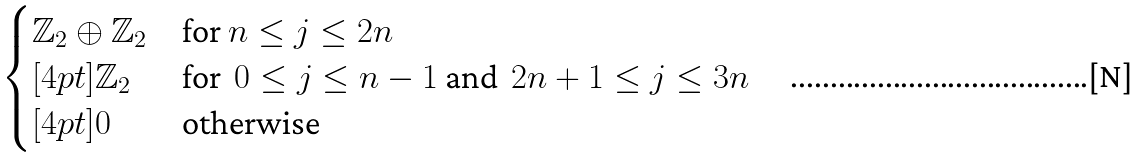<formula> <loc_0><loc_0><loc_500><loc_500>\begin{cases} \mathbb { Z } _ { 2 } \oplus \mathbb { Z } _ { 2 } & \text {for} \ n \leq j \leq 2 n \\ [ 4 p t ] \mathbb { Z } _ { 2 } & \text {for} \ \ 0 \leq j \leq n - 1 \ \text {and} \ \ 2 n + 1 \leq j \leq 3 n \\ [ 4 p t ] 0 & \text {otherwise} \end{cases}</formula> 